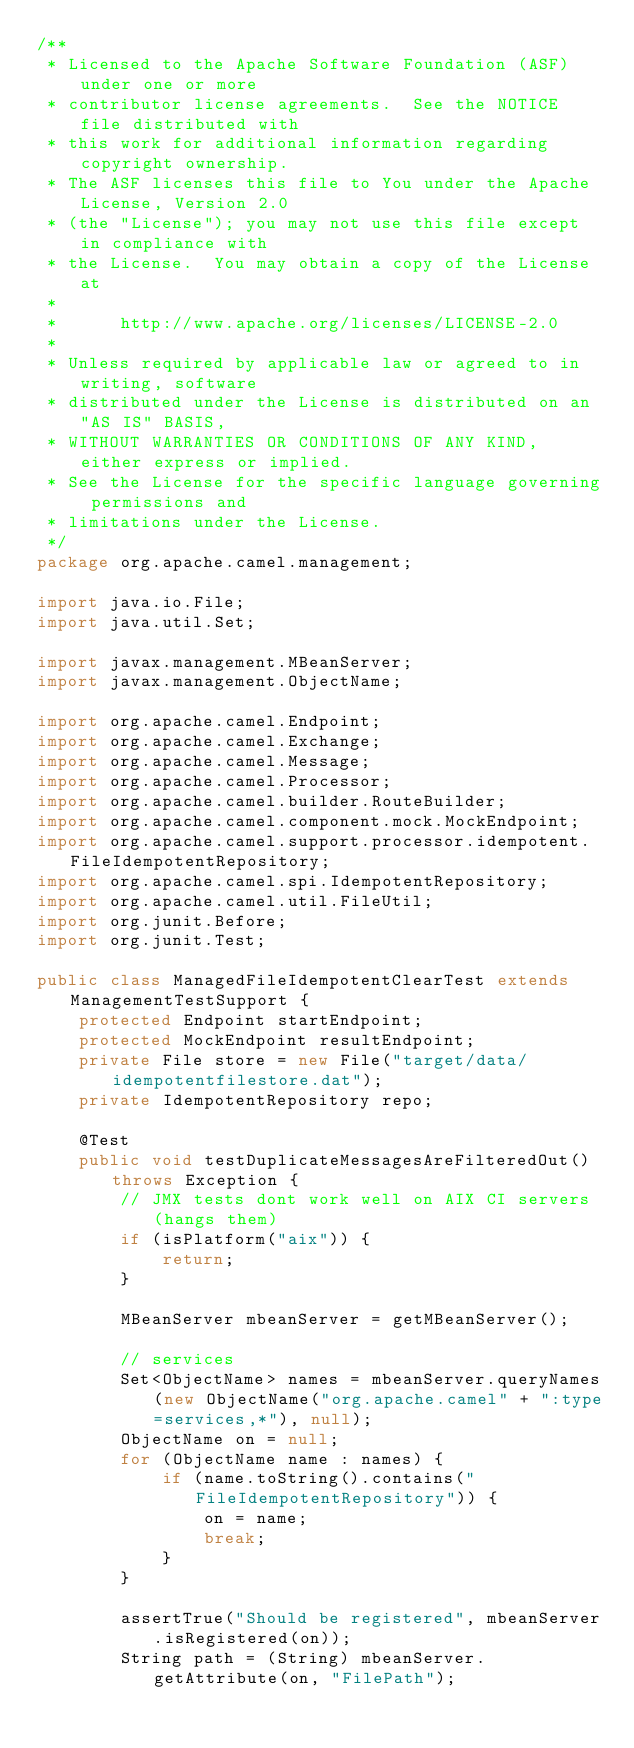Convert code to text. <code><loc_0><loc_0><loc_500><loc_500><_Java_>/**
 * Licensed to the Apache Software Foundation (ASF) under one or more
 * contributor license agreements.  See the NOTICE file distributed with
 * this work for additional information regarding copyright ownership.
 * The ASF licenses this file to You under the Apache License, Version 2.0
 * (the "License"); you may not use this file except in compliance with
 * the License.  You may obtain a copy of the License at
 *
 *      http://www.apache.org/licenses/LICENSE-2.0
 *
 * Unless required by applicable law or agreed to in writing, software
 * distributed under the License is distributed on an "AS IS" BASIS,
 * WITHOUT WARRANTIES OR CONDITIONS OF ANY KIND, either express or implied.
 * See the License for the specific language governing permissions and
 * limitations under the License.
 */
package org.apache.camel.management;

import java.io.File;
import java.util.Set;

import javax.management.MBeanServer;
import javax.management.ObjectName;

import org.apache.camel.Endpoint;
import org.apache.camel.Exchange;
import org.apache.camel.Message;
import org.apache.camel.Processor;
import org.apache.camel.builder.RouteBuilder;
import org.apache.camel.component.mock.MockEndpoint;
import org.apache.camel.support.processor.idempotent.FileIdempotentRepository;
import org.apache.camel.spi.IdempotentRepository;
import org.apache.camel.util.FileUtil;
import org.junit.Before;
import org.junit.Test;

public class ManagedFileIdempotentClearTest extends ManagementTestSupport {
    protected Endpoint startEndpoint;
    protected MockEndpoint resultEndpoint;
    private File store = new File("target/data/idempotentfilestore.dat");
    private IdempotentRepository repo;

    @Test
    public void testDuplicateMessagesAreFilteredOut() throws Exception {
        // JMX tests dont work well on AIX CI servers (hangs them)
        if (isPlatform("aix")) {
            return;
        }

        MBeanServer mbeanServer = getMBeanServer();

        // services
        Set<ObjectName> names = mbeanServer.queryNames(new ObjectName("org.apache.camel" + ":type=services,*"), null);
        ObjectName on = null;
        for (ObjectName name : names) {
            if (name.toString().contains("FileIdempotentRepository")) {
                on = name;
                break;
            }
        }

        assertTrue("Should be registered", mbeanServer.isRegistered(on));
        String path = (String) mbeanServer.getAttribute(on, "FilePath");</code> 